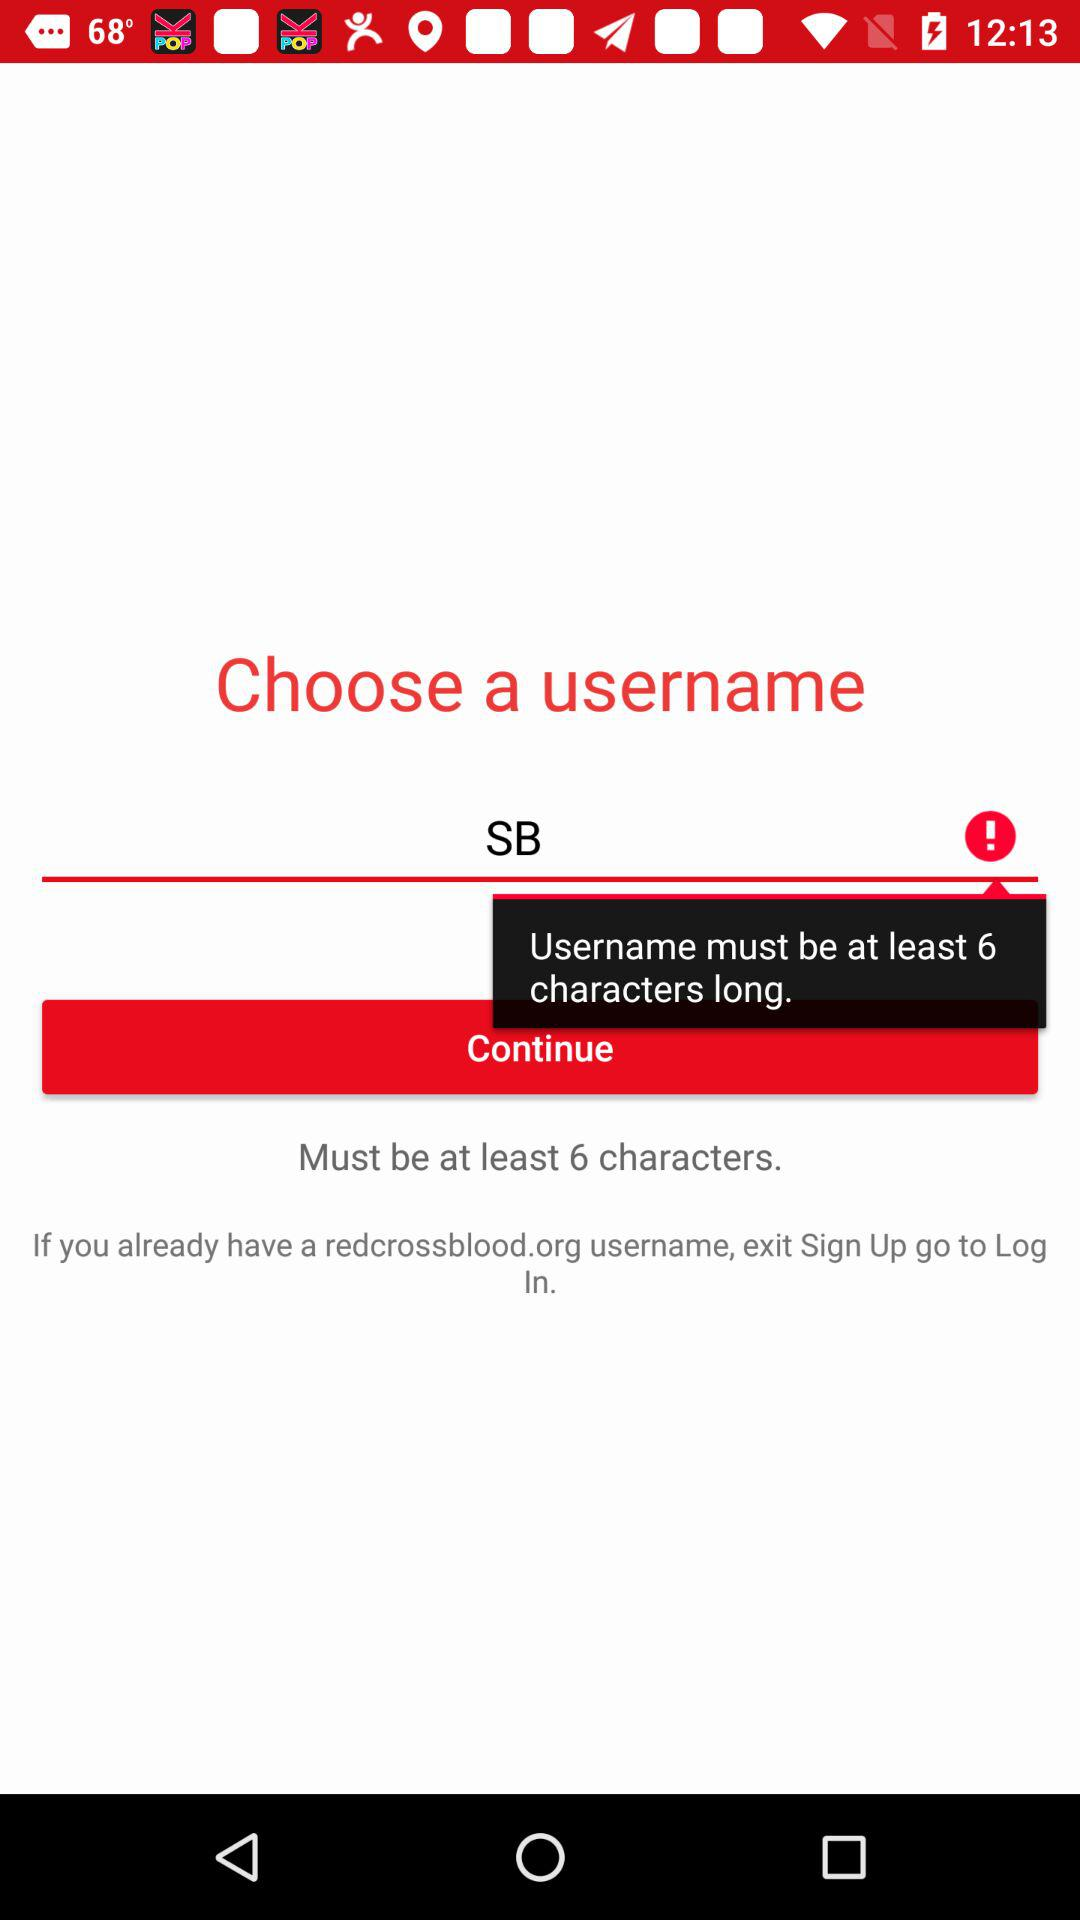What is the user name? The user name is "SB". 